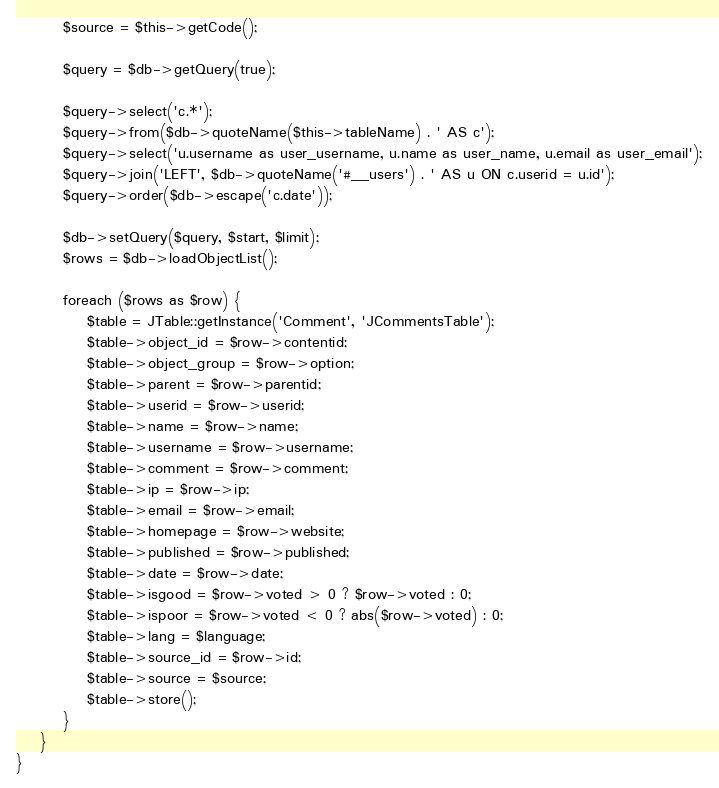<code> <loc_0><loc_0><loc_500><loc_500><_PHP_>		$source = $this->getCode();

		$query = $db->getQuery(true);

		$query->select('c.*');
		$query->from($db->quoteName($this->tableName) . ' AS c');
		$query->select('u.username as user_username, u.name as user_name, u.email as user_email');
		$query->join('LEFT', $db->quoteName('#__users') . ' AS u ON c.userid = u.id');
		$query->order($db->escape('c.date'));

		$db->setQuery($query, $start, $limit);
		$rows = $db->loadObjectList();

		foreach ($rows as $row) {
			$table = JTable::getInstance('Comment', 'JCommentsTable');
			$table->object_id = $row->contentid;
			$table->object_group = $row->option;
			$table->parent = $row->parentid;
			$table->userid = $row->userid;
			$table->name = $row->name;
			$table->username = $row->username;
			$table->comment = $row->comment;
			$table->ip = $row->ip;
			$table->email = $row->email;
			$table->homepage = $row->website;
			$table->published = $row->published;
			$table->date = $row->date;
			$table->isgood = $row->voted > 0 ? $row->voted : 0;
			$table->ispoor = $row->voted < 0 ? abs($row->voted) : 0;
			$table->lang = $language;
			$table->source_id = $row->id;
			$table->source = $source;
			$table->store();
		}
	}
}</code> 